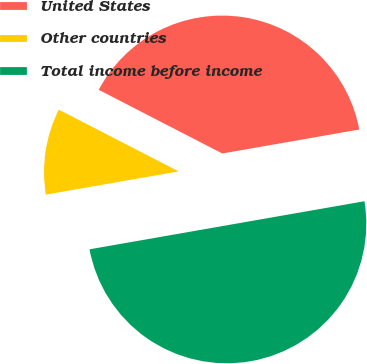Convert chart to OTSL. <chart><loc_0><loc_0><loc_500><loc_500><pie_chart><fcel>United States<fcel>Other countries<fcel>Total income before income<nl><fcel>39.67%<fcel>10.33%<fcel>50.0%<nl></chart> 